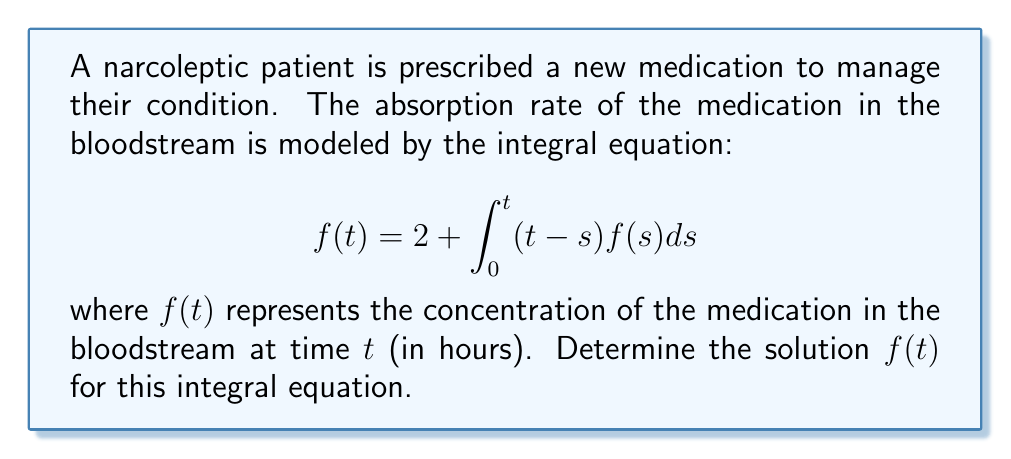Provide a solution to this math problem. To solve this integral equation, we'll use the following steps:

1) First, we recognize this as a Volterra integral equation of the second kind.

2) We can solve this using the method of successive approximations (Picard iteration).

3) Let's start with $f_0(t) = 2$ (the constant term in the equation).

4) For the first iteration:
   $$f_1(t) = 2 + \int_0^t (t-s)f_0(s)ds = 2 + \int_0^t (t-s)2ds = 2 + 2\int_0^t (t-s)ds$$
   $$= 2 + 2[ts - \frac{s^2}{2}]_0^t = 2 + 2(t^2 - \frac{t^2}{2}) = 2 + t^2$$

5) For the second iteration:
   $$f_2(t) = 2 + \int_0^t (t-s)(2+s^2)ds = 2 + 2\int_0^t (t-s)ds + \int_0^t (t-s)s^2ds$$
   $$= 2 + t^2 + [ts^3 - \frac{s^4}{4}]_0^t = 2 + t^2 + (t^4 - \frac{t^4}{4}) = 2 + t^2 + \frac{3t^4}{4}$$

6) We can see a pattern forming. Let's try one more iteration:
   $$f_3(t) = 2 + \int_0^t (t-s)(2+s^2+\frac{3s^4}{4})ds$$
   $$= 2 + t^2 + \frac{3t^4}{4} + \frac{3}{4}\int_0^t (t-s)s^4ds$$
   $$= 2 + t^2 + \frac{3t^4}{4} + \frac{3}{4}[ts^5 - \frac{s^6}{6}]_0^t$$
   $$= 2 + t^2 + \frac{3t^4}{4} + \frac{3}{4}(t^6 - \frac{t^6}{6}) = 2 + t^2 + \frac{3t^4}{4} + \frac{5t^6}{8}$$

7) The pattern suggests that the solution has the form:
   $$f(t) = 2 + t^2 + \frac{3t^4}{4} + \frac{5t^6}{8} + \frac{7t^8}{16} + ...$$

8) This can be written as a power series:
   $$f(t) = 2 + \sum_{n=1}^{\infty} \frac{(2n-1)t^{2n}}{2^n}$$

9) We can verify this solution by substituting it back into the original equation.
Answer: $$f(t) = 2 + \sum_{n=1}^{\infty} \frac{(2n-1)t^{2n}}{2^n}$$ 